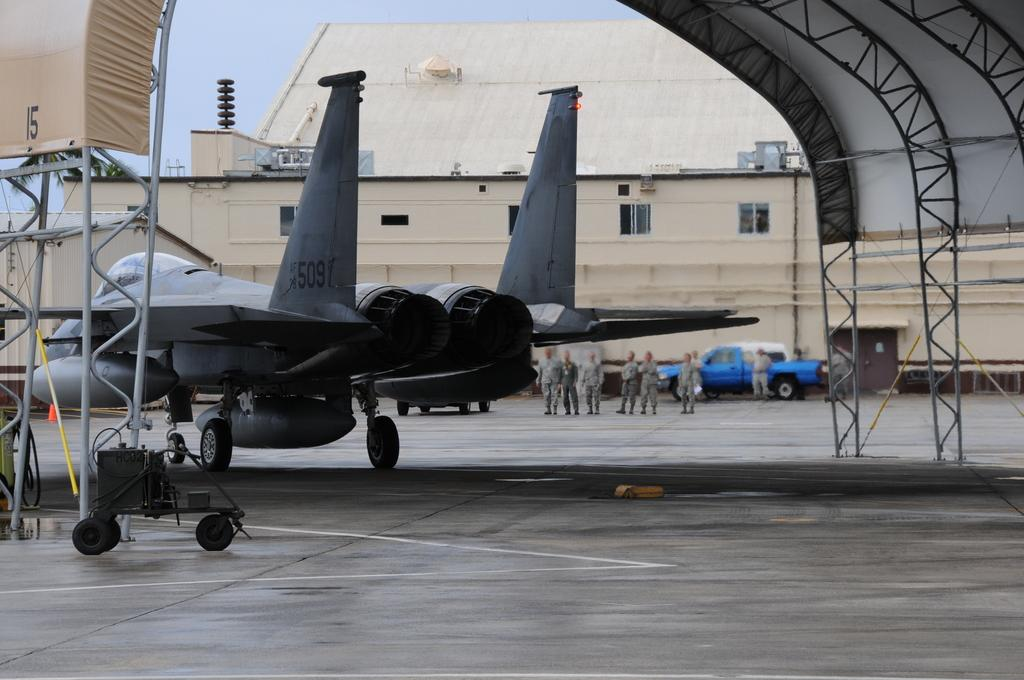<image>
Offer a succinct explanation of the picture presented. A military plane on the ground with a number on its left wing. 